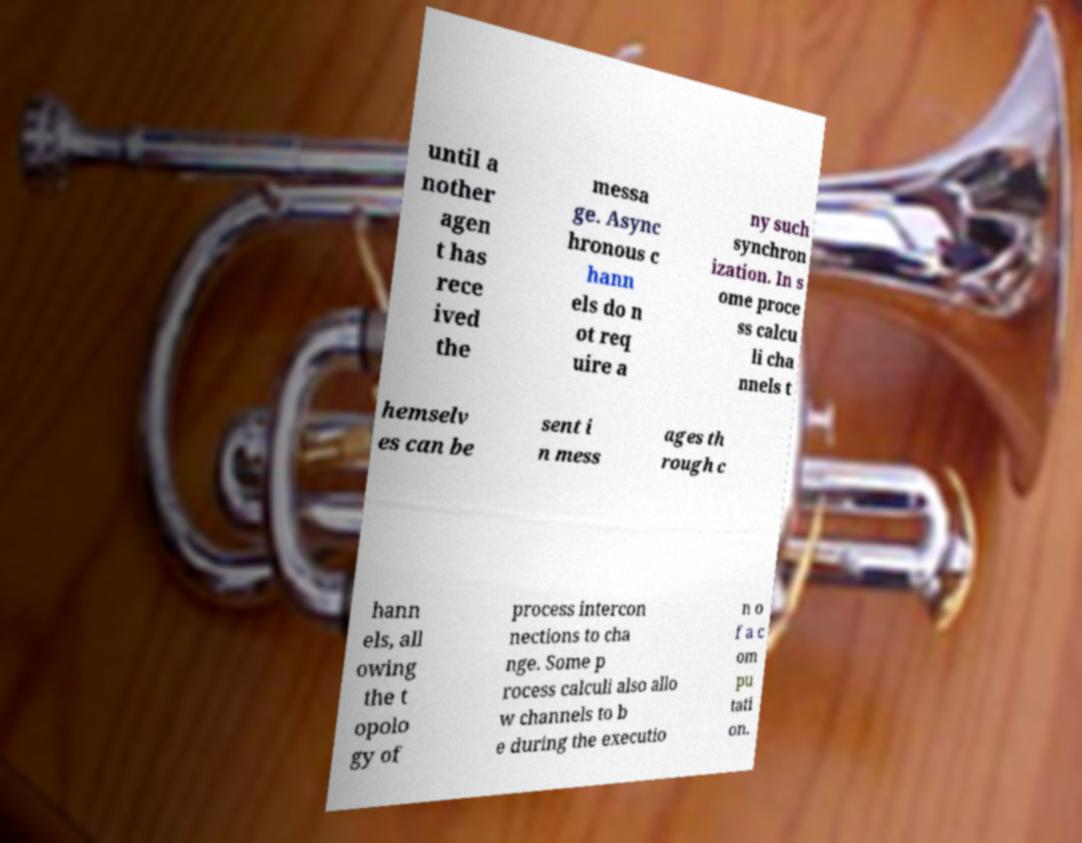For documentation purposes, I need the text within this image transcribed. Could you provide that? until a nother agen t has rece ived the messa ge. Async hronous c hann els do n ot req uire a ny such synchron ization. In s ome proce ss calcu li cha nnels t hemselv es can be sent i n mess ages th rough c hann els, all owing the t opolo gy of process intercon nections to cha nge. Some p rocess calculi also allo w channels to b e during the executio n o f a c om pu tati on. 